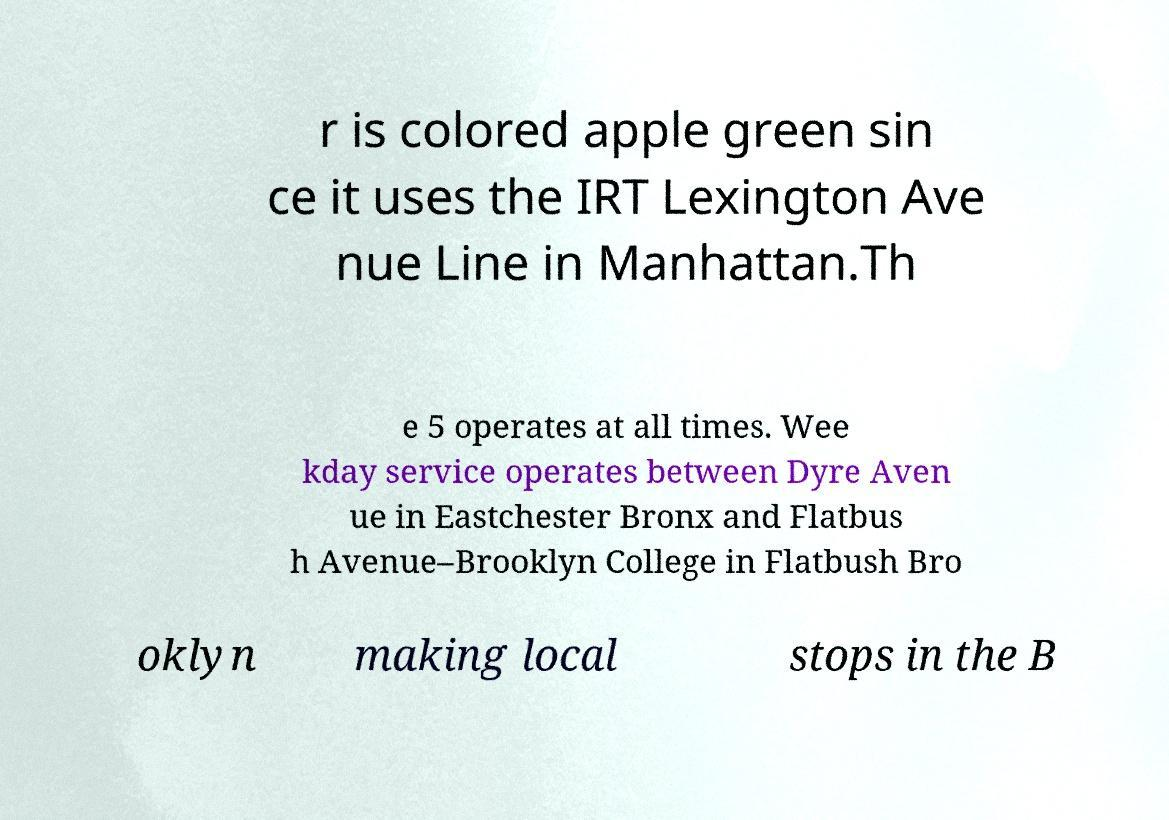Please identify and transcribe the text found in this image. r is colored apple green sin ce it uses the IRT Lexington Ave nue Line in Manhattan.Th e 5 operates at all times. Wee kday service operates between Dyre Aven ue in Eastchester Bronx and Flatbus h Avenue–Brooklyn College in Flatbush Bro oklyn making local stops in the B 